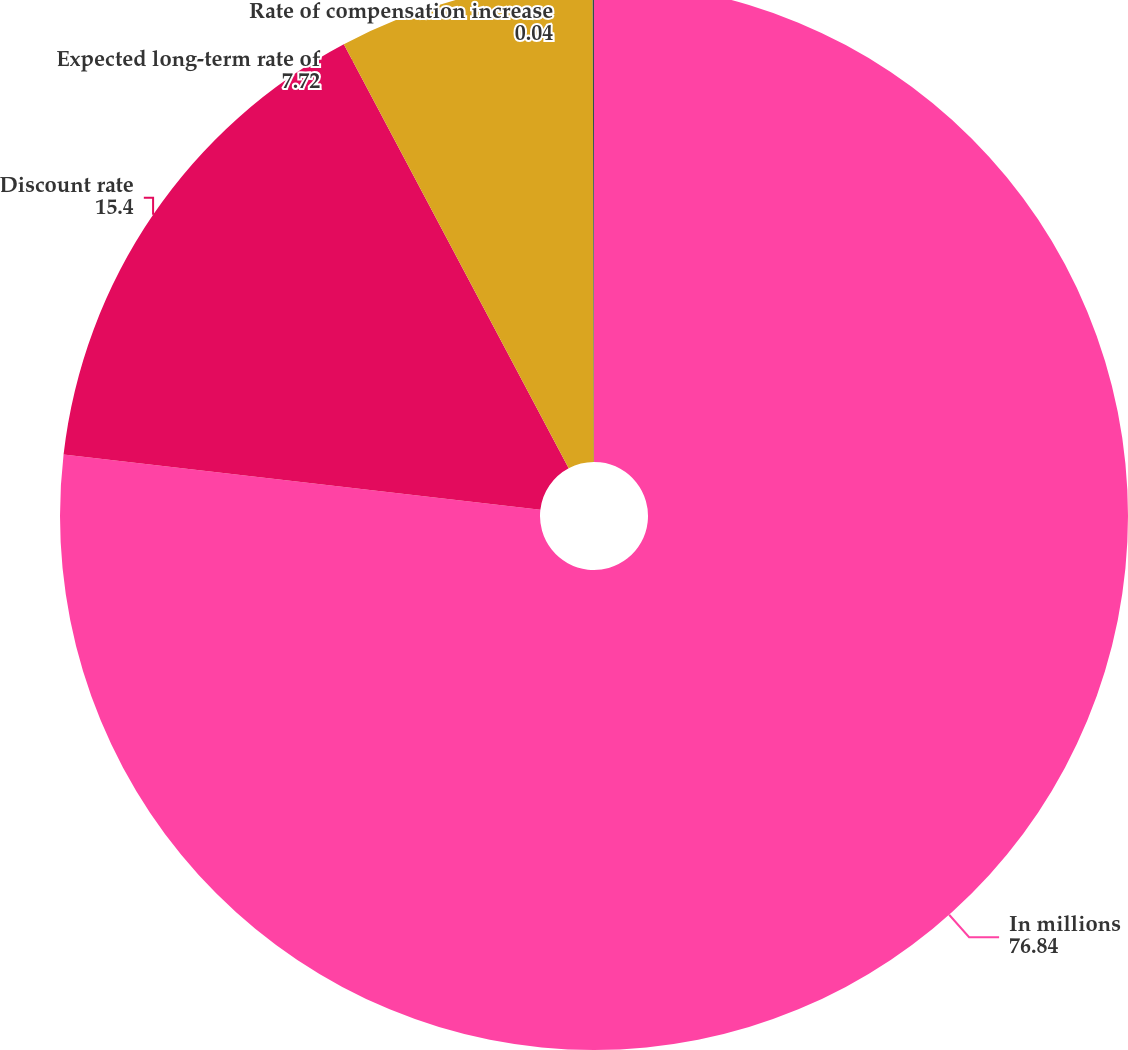Convert chart to OTSL. <chart><loc_0><loc_0><loc_500><loc_500><pie_chart><fcel>In millions<fcel>Discount rate<fcel>Expected long-term rate of<fcel>Rate of compensation increase<nl><fcel>76.84%<fcel>15.4%<fcel>7.72%<fcel>0.04%<nl></chart> 